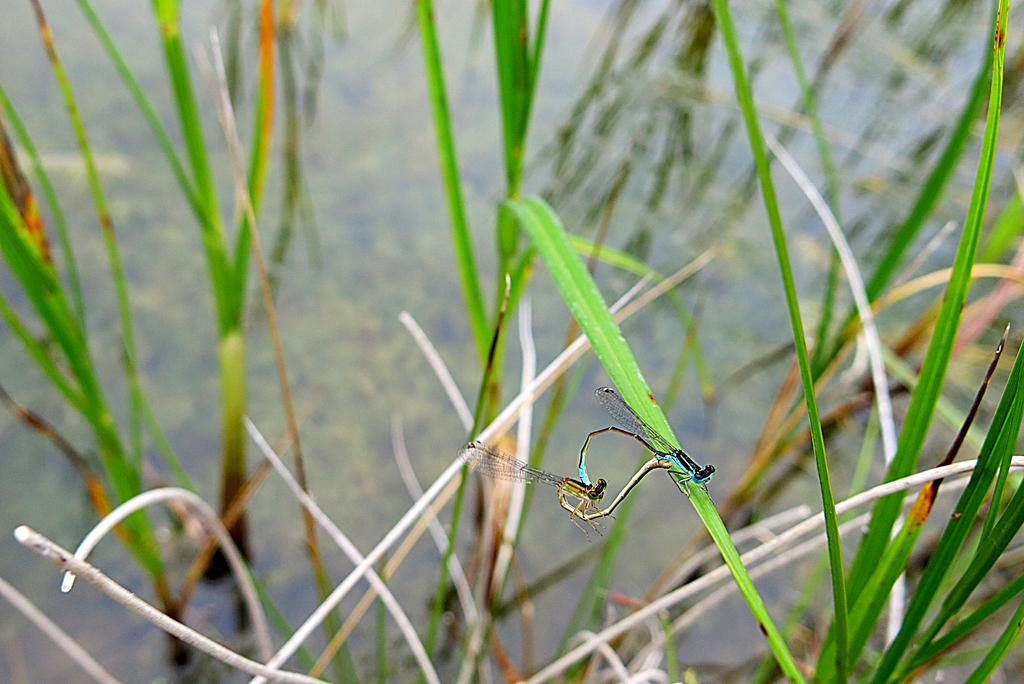What insects can be seen on the grass in the image? There are dragonflies on the grass in the image. What type of environment is visible in the background of the image? There is a water surface visible in the background of the image. Where is the shelf located in the image? There is no shelf present in the image. What type of relation can be observed between the dragonflies in the image? The image does not show any interactions or relationships between the dragonflies, so it cannot be determined from the image. 